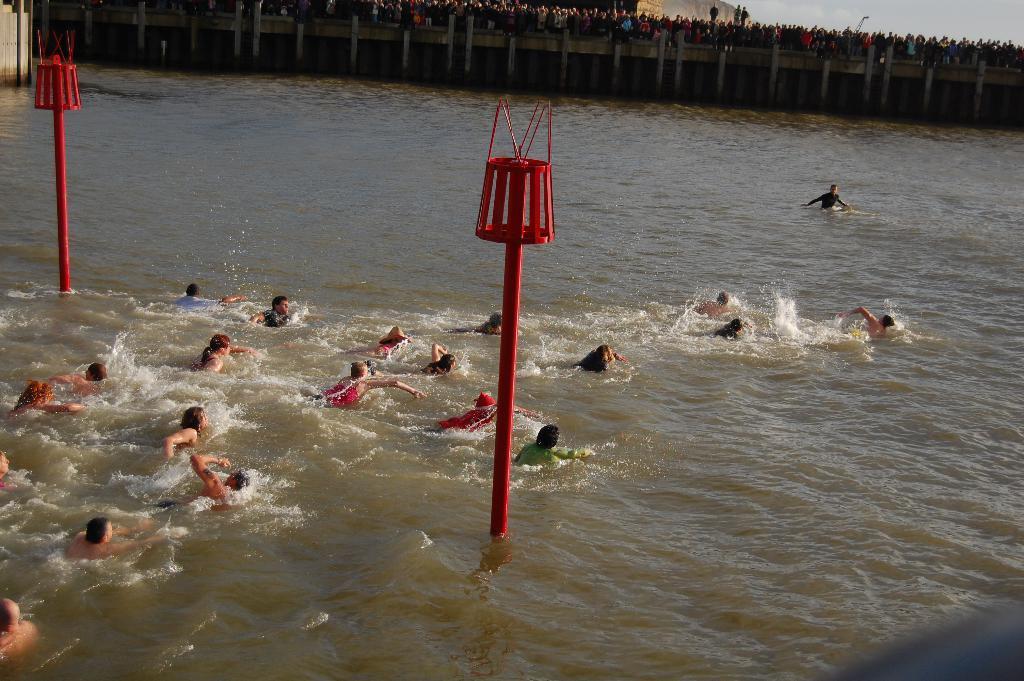In one or two sentences, can you explain what this image depicts? Here in this picture we can see number of people swimming over a place, where we can see water present all over there and in the middle we can see two red colored moles present and in the far we can see walls and we can see people standing and watching them over there. 